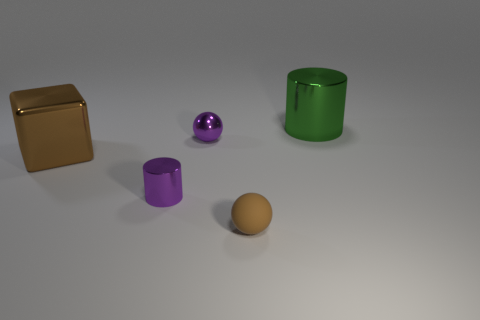Are there any objects of the same color as the tiny cylinder?
Offer a very short reply. Yes. What is the shape of the metal thing that is the same size as the green cylinder?
Offer a terse response. Cube. How many brown things are either large metal cubes or small metal balls?
Offer a terse response. 1. How many purple metal cylinders have the same size as the brown matte object?
Provide a succinct answer. 1. What is the shape of the thing that is the same color as the small cylinder?
Ensure brevity in your answer.  Sphere. How many objects are either small brown balls or big things in front of the purple sphere?
Give a very brief answer. 2. Do the cylinder that is in front of the green cylinder and the purple object that is behind the brown shiny thing have the same size?
Your answer should be very brief. Yes. What number of small blue rubber objects are the same shape as the large green thing?
Offer a very short reply. 0. The big green object that is the same material as the big block is what shape?
Ensure brevity in your answer.  Cylinder. The tiny purple thing right of the metal cylinder in front of the big green shiny cylinder that is right of the big brown shiny object is made of what material?
Provide a short and direct response. Metal. 